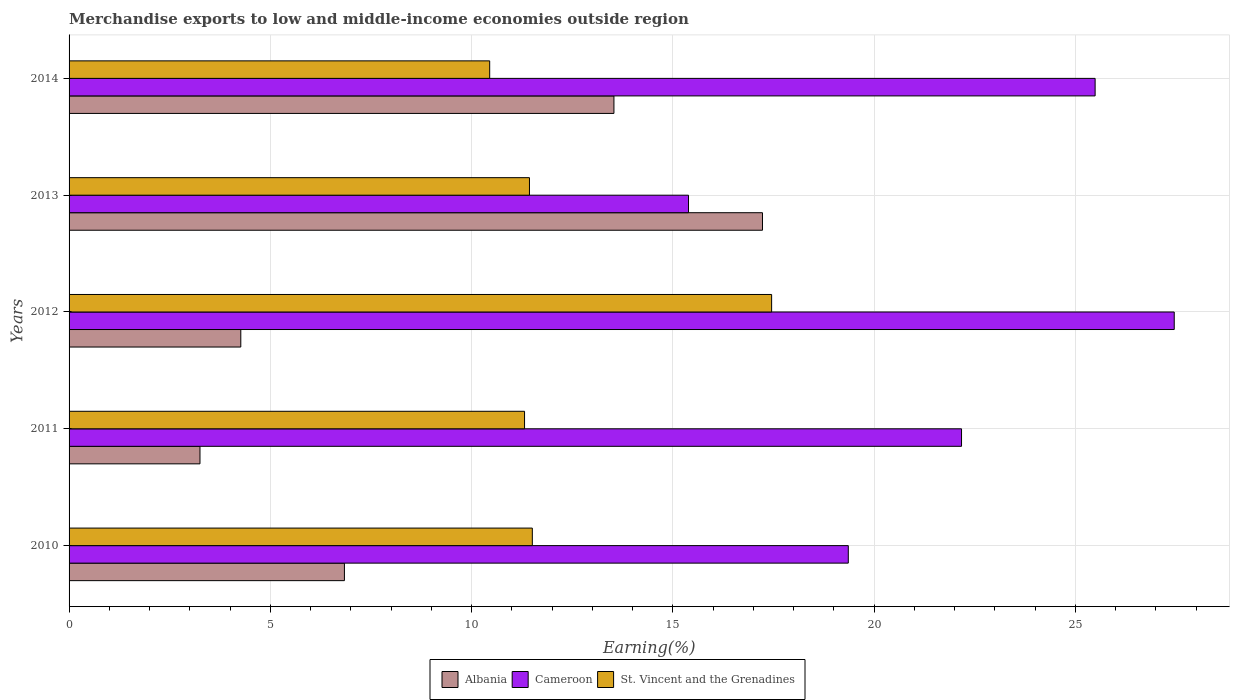Are the number of bars per tick equal to the number of legend labels?
Offer a very short reply. Yes. Are the number of bars on each tick of the Y-axis equal?
Your answer should be very brief. Yes. How many bars are there on the 2nd tick from the top?
Make the answer very short. 3. How many bars are there on the 1st tick from the bottom?
Ensure brevity in your answer.  3. What is the label of the 5th group of bars from the top?
Provide a succinct answer. 2010. What is the percentage of amount earned from merchandise exports in St. Vincent and the Grenadines in 2010?
Provide a succinct answer. 11.51. Across all years, what is the maximum percentage of amount earned from merchandise exports in Albania?
Keep it short and to the point. 17.23. Across all years, what is the minimum percentage of amount earned from merchandise exports in Cameroon?
Provide a short and direct response. 15.39. In which year was the percentage of amount earned from merchandise exports in Albania minimum?
Ensure brevity in your answer.  2011. What is the total percentage of amount earned from merchandise exports in St. Vincent and the Grenadines in the graph?
Ensure brevity in your answer.  62.17. What is the difference between the percentage of amount earned from merchandise exports in Albania in 2010 and that in 2013?
Your response must be concise. -10.39. What is the difference between the percentage of amount earned from merchandise exports in St. Vincent and the Grenadines in 2013 and the percentage of amount earned from merchandise exports in Albania in 2012?
Give a very brief answer. 7.17. What is the average percentage of amount earned from merchandise exports in St. Vincent and the Grenadines per year?
Keep it short and to the point. 12.43. In the year 2013, what is the difference between the percentage of amount earned from merchandise exports in St. Vincent and the Grenadines and percentage of amount earned from merchandise exports in Albania?
Offer a terse response. -5.79. In how many years, is the percentage of amount earned from merchandise exports in Albania greater than 5 %?
Offer a terse response. 3. What is the ratio of the percentage of amount earned from merchandise exports in Albania in 2013 to that in 2014?
Your answer should be compact. 1.27. Is the difference between the percentage of amount earned from merchandise exports in St. Vincent and the Grenadines in 2011 and 2014 greater than the difference between the percentage of amount earned from merchandise exports in Albania in 2011 and 2014?
Offer a terse response. Yes. What is the difference between the highest and the second highest percentage of amount earned from merchandise exports in St. Vincent and the Grenadines?
Keep it short and to the point. 5.95. What is the difference between the highest and the lowest percentage of amount earned from merchandise exports in Albania?
Your answer should be compact. 13.97. What does the 2nd bar from the top in 2014 represents?
Ensure brevity in your answer.  Cameroon. What does the 3rd bar from the bottom in 2012 represents?
Provide a succinct answer. St. Vincent and the Grenadines. Is it the case that in every year, the sum of the percentage of amount earned from merchandise exports in Albania and percentage of amount earned from merchandise exports in Cameroon is greater than the percentage of amount earned from merchandise exports in St. Vincent and the Grenadines?
Your answer should be very brief. Yes. How many bars are there?
Keep it short and to the point. 15. Are all the bars in the graph horizontal?
Ensure brevity in your answer.  Yes. What is the difference between two consecutive major ticks on the X-axis?
Your answer should be very brief. 5. Does the graph contain grids?
Offer a very short reply. Yes. What is the title of the graph?
Offer a terse response. Merchandise exports to low and middle-income economies outside region. Does "Tonga" appear as one of the legend labels in the graph?
Ensure brevity in your answer.  No. What is the label or title of the X-axis?
Your answer should be compact. Earning(%). What is the Earning(%) in Albania in 2010?
Keep it short and to the point. 6.84. What is the Earning(%) of Cameroon in 2010?
Give a very brief answer. 19.36. What is the Earning(%) in St. Vincent and the Grenadines in 2010?
Your response must be concise. 11.51. What is the Earning(%) of Albania in 2011?
Provide a short and direct response. 3.25. What is the Earning(%) in Cameroon in 2011?
Your response must be concise. 22.17. What is the Earning(%) of St. Vincent and the Grenadines in 2011?
Offer a terse response. 11.32. What is the Earning(%) in Albania in 2012?
Provide a succinct answer. 4.27. What is the Earning(%) of Cameroon in 2012?
Your answer should be compact. 27.46. What is the Earning(%) of St. Vincent and the Grenadines in 2012?
Provide a succinct answer. 17.45. What is the Earning(%) in Albania in 2013?
Provide a short and direct response. 17.23. What is the Earning(%) in Cameroon in 2013?
Your response must be concise. 15.39. What is the Earning(%) of St. Vincent and the Grenadines in 2013?
Keep it short and to the point. 11.44. What is the Earning(%) in Albania in 2014?
Give a very brief answer. 13.54. What is the Earning(%) in Cameroon in 2014?
Make the answer very short. 25.49. What is the Earning(%) in St. Vincent and the Grenadines in 2014?
Your answer should be compact. 10.45. Across all years, what is the maximum Earning(%) of Albania?
Your answer should be very brief. 17.23. Across all years, what is the maximum Earning(%) in Cameroon?
Keep it short and to the point. 27.46. Across all years, what is the maximum Earning(%) in St. Vincent and the Grenadines?
Keep it short and to the point. 17.45. Across all years, what is the minimum Earning(%) of Albania?
Provide a succinct answer. 3.25. Across all years, what is the minimum Earning(%) in Cameroon?
Make the answer very short. 15.39. Across all years, what is the minimum Earning(%) of St. Vincent and the Grenadines?
Keep it short and to the point. 10.45. What is the total Earning(%) in Albania in the graph?
Ensure brevity in your answer.  45.12. What is the total Earning(%) of Cameroon in the graph?
Your answer should be compact. 109.87. What is the total Earning(%) of St. Vincent and the Grenadines in the graph?
Make the answer very short. 62.17. What is the difference between the Earning(%) of Albania in 2010 and that in 2011?
Make the answer very short. 3.59. What is the difference between the Earning(%) of Cameroon in 2010 and that in 2011?
Give a very brief answer. -2.81. What is the difference between the Earning(%) in St. Vincent and the Grenadines in 2010 and that in 2011?
Your response must be concise. 0.19. What is the difference between the Earning(%) of Albania in 2010 and that in 2012?
Make the answer very short. 2.57. What is the difference between the Earning(%) of Cameroon in 2010 and that in 2012?
Give a very brief answer. -8.1. What is the difference between the Earning(%) in St. Vincent and the Grenadines in 2010 and that in 2012?
Provide a succinct answer. -5.95. What is the difference between the Earning(%) of Albania in 2010 and that in 2013?
Offer a very short reply. -10.39. What is the difference between the Earning(%) of Cameroon in 2010 and that in 2013?
Give a very brief answer. 3.97. What is the difference between the Earning(%) in St. Vincent and the Grenadines in 2010 and that in 2013?
Keep it short and to the point. 0.07. What is the difference between the Earning(%) of Albania in 2010 and that in 2014?
Offer a very short reply. -6.7. What is the difference between the Earning(%) of Cameroon in 2010 and that in 2014?
Provide a short and direct response. -6.13. What is the difference between the Earning(%) in St. Vincent and the Grenadines in 2010 and that in 2014?
Offer a terse response. 1.06. What is the difference between the Earning(%) in Albania in 2011 and that in 2012?
Make the answer very short. -1.01. What is the difference between the Earning(%) in Cameroon in 2011 and that in 2012?
Offer a very short reply. -5.28. What is the difference between the Earning(%) of St. Vincent and the Grenadines in 2011 and that in 2012?
Keep it short and to the point. -6.14. What is the difference between the Earning(%) of Albania in 2011 and that in 2013?
Offer a terse response. -13.97. What is the difference between the Earning(%) of Cameroon in 2011 and that in 2013?
Your answer should be very brief. 6.78. What is the difference between the Earning(%) in St. Vincent and the Grenadines in 2011 and that in 2013?
Your response must be concise. -0.12. What is the difference between the Earning(%) in Albania in 2011 and that in 2014?
Offer a very short reply. -10.28. What is the difference between the Earning(%) in Cameroon in 2011 and that in 2014?
Offer a terse response. -3.32. What is the difference between the Earning(%) in St. Vincent and the Grenadines in 2011 and that in 2014?
Give a very brief answer. 0.87. What is the difference between the Earning(%) in Albania in 2012 and that in 2013?
Offer a very short reply. -12.96. What is the difference between the Earning(%) in Cameroon in 2012 and that in 2013?
Keep it short and to the point. 12.07. What is the difference between the Earning(%) in St. Vincent and the Grenadines in 2012 and that in 2013?
Your answer should be very brief. 6.02. What is the difference between the Earning(%) of Albania in 2012 and that in 2014?
Your answer should be very brief. -9.27. What is the difference between the Earning(%) in Cameroon in 2012 and that in 2014?
Give a very brief answer. 1.97. What is the difference between the Earning(%) of St. Vincent and the Grenadines in 2012 and that in 2014?
Offer a very short reply. 7. What is the difference between the Earning(%) in Albania in 2013 and that in 2014?
Offer a very short reply. 3.69. What is the difference between the Earning(%) in Cameroon in 2013 and that in 2014?
Offer a terse response. -10.1. What is the difference between the Earning(%) of St. Vincent and the Grenadines in 2013 and that in 2014?
Keep it short and to the point. 0.99. What is the difference between the Earning(%) in Albania in 2010 and the Earning(%) in Cameroon in 2011?
Your answer should be compact. -15.33. What is the difference between the Earning(%) in Albania in 2010 and the Earning(%) in St. Vincent and the Grenadines in 2011?
Offer a very short reply. -4.47. What is the difference between the Earning(%) in Cameroon in 2010 and the Earning(%) in St. Vincent and the Grenadines in 2011?
Provide a succinct answer. 8.04. What is the difference between the Earning(%) of Albania in 2010 and the Earning(%) of Cameroon in 2012?
Offer a very short reply. -20.62. What is the difference between the Earning(%) in Albania in 2010 and the Earning(%) in St. Vincent and the Grenadines in 2012?
Provide a short and direct response. -10.61. What is the difference between the Earning(%) of Cameroon in 2010 and the Earning(%) of St. Vincent and the Grenadines in 2012?
Offer a terse response. 1.9. What is the difference between the Earning(%) in Albania in 2010 and the Earning(%) in Cameroon in 2013?
Provide a short and direct response. -8.55. What is the difference between the Earning(%) in Albania in 2010 and the Earning(%) in St. Vincent and the Grenadines in 2013?
Offer a terse response. -4.6. What is the difference between the Earning(%) of Cameroon in 2010 and the Earning(%) of St. Vincent and the Grenadines in 2013?
Make the answer very short. 7.92. What is the difference between the Earning(%) of Albania in 2010 and the Earning(%) of Cameroon in 2014?
Offer a very short reply. -18.65. What is the difference between the Earning(%) of Albania in 2010 and the Earning(%) of St. Vincent and the Grenadines in 2014?
Your response must be concise. -3.61. What is the difference between the Earning(%) of Cameroon in 2010 and the Earning(%) of St. Vincent and the Grenadines in 2014?
Offer a terse response. 8.91. What is the difference between the Earning(%) of Albania in 2011 and the Earning(%) of Cameroon in 2012?
Your response must be concise. -24.2. What is the difference between the Earning(%) in Albania in 2011 and the Earning(%) in St. Vincent and the Grenadines in 2012?
Keep it short and to the point. -14.2. What is the difference between the Earning(%) of Cameroon in 2011 and the Earning(%) of St. Vincent and the Grenadines in 2012?
Your response must be concise. 4.72. What is the difference between the Earning(%) in Albania in 2011 and the Earning(%) in Cameroon in 2013?
Your answer should be compact. -12.14. What is the difference between the Earning(%) in Albania in 2011 and the Earning(%) in St. Vincent and the Grenadines in 2013?
Your answer should be compact. -8.19. What is the difference between the Earning(%) of Cameroon in 2011 and the Earning(%) of St. Vincent and the Grenadines in 2013?
Your answer should be compact. 10.73. What is the difference between the Earning(%) in Albania in 2011 and the Earning(%) in Cameroon in 2014?
Make the answer very short. -22.24. What is the difference between the Earning(%) of Albania in 2011 and the Earning(%) of St. Vincent and the Grenadines in 2014?
Make the answer very short. -7.2. What is the difference between the Earning(%) of Cameroon in 2011 and the Earning(%) of St. Vincent and the Grenadines in 2014?
Give a very brief answer. 11.72. What is the difference between the Earning(%) in Albania in 2012 and the Earning(%) in Cameroon in 2013?
Your answer should be compact. -11.12. What is the difference between the Earning(%) of Albania in 2012 and the Earning(%) of St. Vincent and the Grenadines in 2013?
Offer a very short reply. -7.17. What is the difference between the Earning(%) of Cameroon in 2012 and the Earning(%) of St. Vincent and the Grenadines in 2013?
Your response must be concise. 16.02. What is the difference between the Earning(%) of Albania in 2012 and the Earning(%) of Cameroon in 2014?
Your answer should be compact. -21.22. What is the difference between the Earning(%) in Albania in 2012 and the Earning(%) in St. Vincent and the Grenadines in 2014?
Your response must be concise. -6.18. What is the difference between the Earning(%) of Cameroon in 2012 and the Earning(%) of St. Vincent and the Grenadines in 2014?
Offer a terse response. 17.01. What is the difference between the Earning(%) of Albania in 2013 and the Earning(%) of Cameroon in 2014?
Your answer should be compact. -8.26. What is the difference between the Earning(%) in Albania in 2013 and the Earning(%) in St. Vincent and the Grenadines in 2014?
Provide a short and direct response. 6.78. What is the difference between the Earning(%) of Cameroon in 2013 and the Earning(%) of St. Vincent and the Grenadines in 2014?
Offer a very short reply. 4.94. What is the average Earning(%) of Albania per year?
Offer a very short reply. 9.02. What is the average Earning(%) of Cameroon per year?
Provide a short and direct response. 21.97. What is the average Earning(%) in St. Vincent and the Grenadines per year?
Keep it short and to the point. 12.43. In the year 2010, what is the difference between the Earning(%) of Albania and Earning(%) of Cameroon?
Your response must be concise. -12.52. In the year 2010, what is the difference between the Earning(%) in Albania and Earning(%) in St. Vincent and the Grenadines?
Offer a very short reply. -4.67. In the year 2010, what is the difference between the Earning(%) of Cameroon and Earning(%) of St. Vincent and the Grenadines?
Offer a terse response. 7.85. In the year 2011, what is the difference between the Earning(%) of Albania and Earning(%) of Cameroon?
Offer a terse response. -18.92. In the year 2011, what is the difference between the Earning(%) of Albania and Earning(%) of St. Vincent and the Grenadines?
Keep it short and to the point. -8.06. In the year 2011, what is the difference between the Earning(%) of Cameroon and Earning(%) of St. Vincent and the Grenadines?
Your answer should be compact. 10.86. In the year 2012, what is the difference between the Earning(%) of Albania and Earning(%) of Cameroon?
Your response must be concise. -23.19. In the year 2012, what is the difference between the Earning(%) in Albania and Earning(%) in St. Vincent and the Grenadines?
Provide a short and direct response. -13.19. In the year 2012, what is the difference between the Earning(%) of Cameroon and Earning(%) of St. Vincent and the Grenadines?
Ensure brevity in your answer.  10. In the year 2013, what is the difference between the Earning(%) of Albania and Earning(%) of Cameroon?
Offer a terse response. 1.84. In the year 2013, what is the difference between the Earning(%) in Albania and Earning(%) in St. Vincent and the Grenadines?
Offer a terse response. 5.79. In the year 2013, what is the difference between the Earning(%) of Cameroon and Earning(%) of St. Vincent and the Grenadines?
Make the answer very short. 3.95. In the year 2014, what is the difference between the Earning(%) in Albania and Earning(%) in Cameroon?
Offer a terse response. -11.95. In the year 2014, what is the difference between the Earning(%) in Albania and Earning(%) in St. Vincent and the Grenadines?
Offer a terse response. 3.09. In the year 2014, what is the difference between the Earning(%) of Cameroon and Earning(%) of St. Vincent and the Grenadines?
Your answer should be very brief. 15.04. What is the ratio of the Earning(%) in Albania in 2010 to that in 2011?
Your response must be concise. 2.1. What is the ratio of the Earning(%) of Cameroon in 2010 to that in 2011?
Keep it short and to the point. 0.87. What is the ratio of the Earning(%) in St. Vincent and the Grenadines in 2010 to that in 2011?
Your response must be concise. 1.02. What is the ratio of the Earning(%) of Albania in 2010 to that in 2012?
Offer a very short reply. 1.6. What is the ratio of the Earning(%) in Cameroon in 2010 to that in 2012?
Keep it short and to the point. 0.71. What is the ratio of the Earning(%) in St. Vincent and the Grenadines in 2010 to that in 2012?
Provide a short and direct response. 0.66. What is the ratio of the Earning(%) in Albania in 2010 to that in 2013?
Give a very brief answer. 0.4. What is the ratio of the Earning(%) in Cameroon in 2010 to that in 2013?
Keep it short and to the point. 1.26. What is the ratio of the Earning(%) in Albania in 2010 to that in 2014?
Your response must be concise. 0.51. What is the ratio of the Earning(%) of Cameroon in 2010 to that in 2014?
Offer a very short reply. 0.76. What is the ratio of the Earning(%) in St. Vincent and the Grenadines in 2010 to that in 2014?
Ensure brevity in your answer.  1.1. What is the ratio of the Earning(%) in Albania in 2011 to that in 2012?
Provide a short and direct response. 0.76. What is the ratio of the Earning(%) of Cameroon in 2011 to that in 2012?
Provide a short and direct response. 0.81. What is the ratio of the Earning(%) in St. Vincent and the Grenadines in 2011 to that in 2012?
Your response must be concise. 0.65. What is the ratio of the Earning(%) in Albania in 2011 to that in 2013?
Offer a very short reply. 0.19. What is the ratio of the Earning(%) of Cameroon in 2011 to that in 2013?
Your answer should be very brief. 1.44. What is the ratio of the Earning(%) of St. Vincent and the Grenadines in 2011 to that in 2013?
Offer a very short reply. 0.99. What is the ratio of the Earning(%) in Albania in 2011 to that in 2014?
Provide a succinct answer. 0.24. What is the ratio of the Earning(%) of Cameroon in 2011 to that in 2014?
Keep it short and to the point. 0.87. What is the ratio of the Earning(%) in St. Vincent and the Grenadines in 2011 to that in 2014?
Offer a terse response. 1.08. What is the ratio of the Earning(%) in Albania in 2012 to that in 2013?
Provide a short and direct response. 0.25. What is the ratio of the Earning(%) in Cameroon in 2012 to that in 2013?
Your answer should be compact. 1.78. What is the ratio of the Earning(%) of St. Vincent and the Grenadines in 2012 to that in 2013?
Your answer should be compact. 1.53. What is the ratio of the Earning(%) in Albania in 2012 to that in 2014?
Your response must be concise. 0.32. What is the ratio of the Earning(%) of Cameroon in 2012 to that in 2014?
Provide a succinct answer. 1.08. What is the ratio of the Earning(%) in St. Vincent and the Grenadines in 2012 to that in 2014?
Your answer should be very brief. 1.67. What is the ratio of the Earning(%) in Albania in 2013 to that in 2014?
Offer a very short reply. 1.27. What is the ratio of the Earning(%) of Cameroon in 2013 to that in 2014?
Your answer should be compact. 0.6. What is the ratio of the Earning(%) of St. Vincent and the Grenadines in 2013 to that in 2014?
Your response must be concise. 1.09. What is the difference between the highest and the second highest Earning(%) in Albania?
Provide a short and direct response. 3.69. What is the difference between the highest and the second highest Earning(%) in Cameroon?
Your answer should be compact. 1.97. What is the difference between the highest and the second highest Earning(%) of St. Vincent and the Grenadines?
Offer a very short reply. 5.95. What is the difference between the highest and the lowest Earning(%) in Albania?
Offer a very short reply. 13.97. What is the difference between the highest and the lowest Earning(%) of Cameroon?
Keep it short and to the point. 12.07. What is the difference between the highest and the lowest Earning(%) of St. Vincent and the Grenadines?
Your response must be concise. 7. 